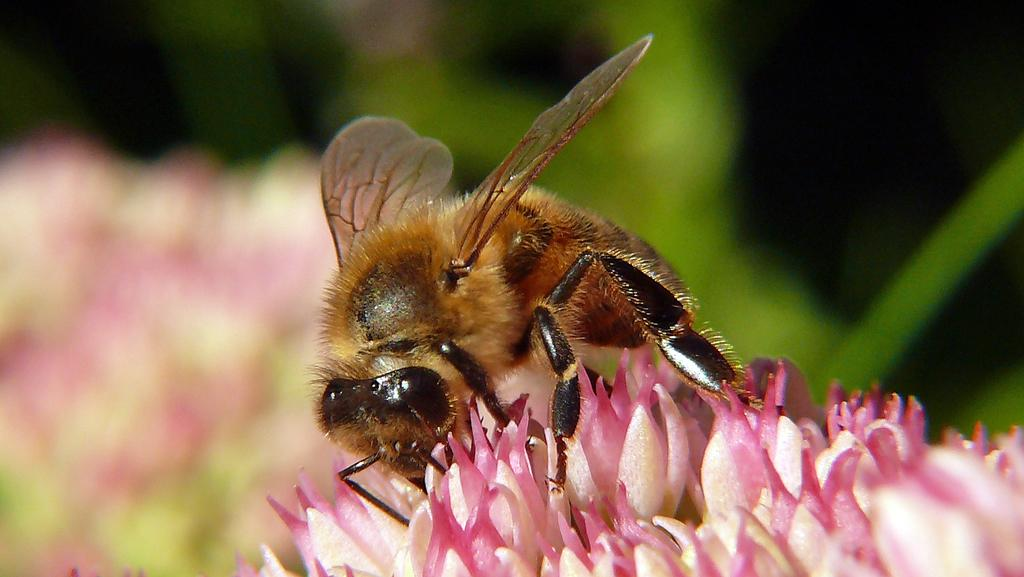What type of creature is present in the image? There is an insect in the image. Where is the insect located in the image? The insect is on flowers. Can you describe the background of the image? The background of the image is blurred. What type of journey is the pear embarking on in the image? There is no pear present in the image, and therefore no such journey can be observed. What type of fruit is visible in the image? There is no fruit visible in the image; it features an insect on flowers. 